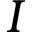<formula> <loc_0><loc_0><loc_500><loc_500>I</formula> 